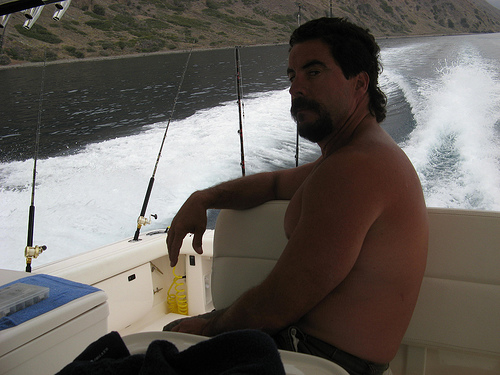<image>
Is the water in front of the man? No. The water is not in front of the man. The spatial positioning shows a different relationship between these objects. 